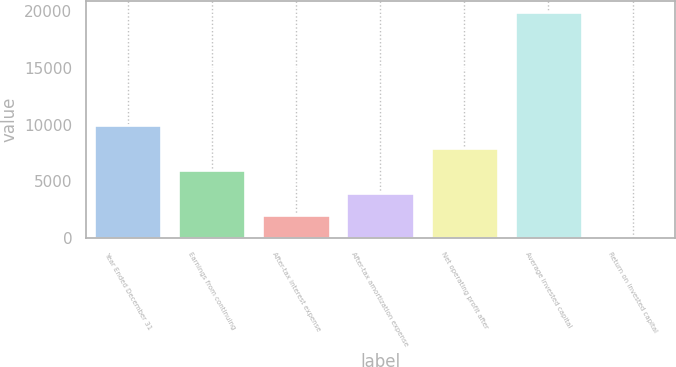Convert chart to OTSL. <chart><loc_0><loc_0><loc_500><loc_500><bar_chart><fcel>Year Ended December 31<fcel>Earnings from continuing<fcel>After-tax interest expense<fcel>After-tax amortization expense<fcel>Net operating profit after<fcel>Average invested capital<fcel>Return on invested capital<nl><fcel>9953.7<fcel>5975.58<fcel>1997.46<fcel>3986.52<fcel>7964.64<fcel>19899<fcel>8.4<nl></chart> 